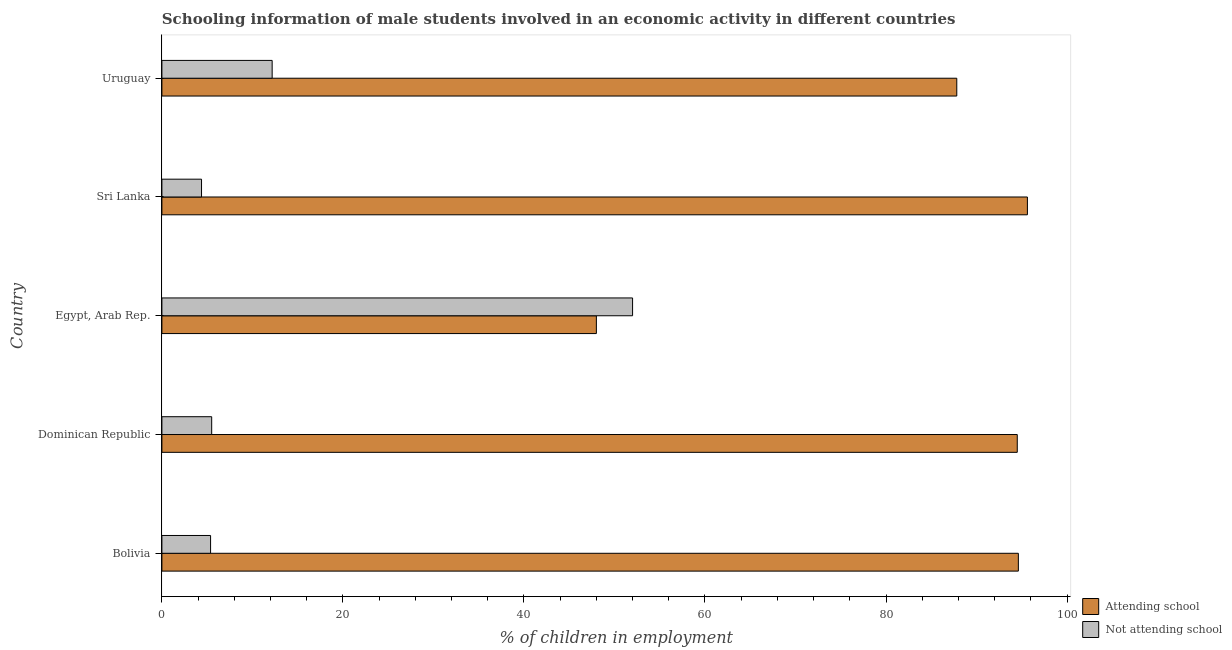How many groups of bars are there?
Your response must be concise. 5. How many bars are there on the 1st tick from the top?
Provide a succinct answer. 2. How many bars are there on the 5th tick from the bottom?
Make the answer very short. 2. What is the label of the 1st group of bars from the top?
Offer a very short reply. Uruguay. In how many cases, is the number of bars for a given country not equal to the number of legend labels?
Your answer should be very brief. 0. What is the percentage of employed males who are attending school in Sri Lanka?
Keep it short and to the point. 95.62. Across all countries, what is the minimum percentage of employed males who are not attending school?
Your response must be concise. 4.38. In which country was the percentage of employed males who are not attending school maximum?
Offer a very short reply. Egypt, Arab Rep. In which country was the percentage of employed males who are attending school minimum?
Give a very brief answer. Egypt, Arab Rep. What is the total percentage of employed males who are attending school in the graph?
Offer a terse response. 420.56. What is the difference between the percentage of employed males who are attending school in Egypt, Arab Rep. and that in Uruguay?
Make the answer very short. -39.82. What is the difference between the percentage of employed males who are not attending school in Bolivia and the percentage of employed males who are attending school in Uruguay?
Make the answer very short. -82.44. What is the average percentage of employed males who are not attending school per country?
Keep it short and to the point. 15.89. What is the difference between the percentage of employed males who are attending school and percentage of employed males who are not attending school in Bolivia?
Provide a short and direct response. 89.24. In how many countries, is the percentage of employed males who are attending school greater than 28 %?
Ensure brevity in your answer.  5. What is the ratio of the percentage of employed males who are not attending school in Egypt, Arab Rep. to that in Uruguay?
Your response must be concise. 4.27. Is the percentage of employed males who are not attending school in Bolivia less than that in Uruguay?
Your response must be concise. Yes. What is the difference between the highest and the second highest percentage of employed males who are attending school?
Provide a succinct answer. 1. What is the difference between the highest and the lowest percentage of employed males who are attending school?
Offer a terse response. 47.62. What does the 2nd bar from the top in Bolivia represents?
Offer a very short reply. Attending school. What does the 1st bar from the bottom in Egypt, Arab Rep. represents?
Provide a short and direct response. Attending school. How many bars are there?
Offer a very short reply. 10. Are all the bars in the graph horizontal?
Provide a succinct answer. Yes. What is the difference between two consecutive major ticks on the X-axis?
Give a very brief answer. 20. Are the values on the major ticks of X-axis written in scientific E-notation?
Provide a short and direct response. No. Does the graph contain any zero values?
Offer a very short reply. No. Where does the legend appear in the graph?
Keep it short and to the point. Bottom right. How many legend labels are there?
Offer a terse response. 2. What is the title of the graph?
Offer a very short reply. Schooling information of male students involved in an economic activity in different countries. What is the label or title of the X-axis?
Your response must be concise. % of children in employment. What is the % of children in employment of Attending school in Bolivia?
Make the answer very short. 94.62. What is the % of children in employment of Not attending school in Bolivia?
Make the answer very short. 5.38. What is the % of children in employment of Attending school in Dominican Republic?
Provide a succinct answer. 94.5. What is the % of children in employment in Not attending school in Egypt, Arab Rep.?
Keep it short and to the point. 52. What is the % of children in employment of Attending school in Sri Lanka?
Offer a very short reply. 95.62. What is the % of children in employment of Not attending school in Sri Lanka?
Offer a very short reply. 4.38. What is the % of children in employment of Attending school in Uruguay?
Keep it short and to the point. 87.82. What is the % of children in employment of Not attending school in Uruguay?
Offer a terse response. 12.18. Across all countries, what is the maximum % of children in employment in Attending school?
Provide a short and direct response. 95.62. Across all countries, what is the minimum % of children in employment in Not attending school?
Your answer should be compact. 4.38. What is the total % of children in employment in Attending school in the graph?
Your answer should be very brief. 420.56. What is the total % of children in employment in Not attending school in the graph?
Provide a succinct answer. 79.44. What is the difference between the % of children in employment of Attending school in Bolivia and that in Dominican Republic?
Provide a short and direct response. 0.12. What is the difference between the % of children in employment in Not attending school in Bolivia and that in Dominican Republic?
Make the answer very short. -0.12. What is the difference between the % of children in employment of Attending school in Bolivia and that in Egypt, Arab Rep.?
Provide a succinct answer. 46.62. What is the difference between the % of children in employment in Not attending school in Bolivia and that in Egypt, Arab Rep.?
Offer a very short reply. -46.62. What is the difference between the % of children in employment in Attending school in Bolivia and that in Sri Lanka?
Your answer should be compact. -1. What is the difference between the % of children in employment in Attending school in Bolivia and that in Uruguay?
Provide a succinct answer. 6.8. What is the difference between the % of children in employment in Not attending school in Bolivia and that in Uruguay?
Provide a succinct answer. -6.8. What is the difference between the % of children in employment in Attending school in Dominican Republic and that in Egypt, Arab Rep.?
Your answer should be very brief. 46.5. What is the difference between the % of children in employment in Not attending school in Dominican Republic and that in Egypt, Arab Rep.?
Ensure brevity in your answer.  -46.5. What is the difference between the % of children in employment of Attending school in Dominican Republic and that in Sri Lanka?
Give a very brief answer. -1.12. What is the difference between the % of children in employment of Not attending school in Dominican Republic and that in Sri Lanka?
Offer a terse response. 1.12. What is the difference between the % of children in employment in Attending school in Dominican Republic and that in Uruguay?
Provide a short and direct response. 6.68. What is the difference between the % of children in employment in Not attending school in Dominican Republic and that in Uruguay?
Keep it short and to the point. -6.68. What is the difference between the % of children in employment of Attending school in Egypt, Arab Rep. and that in Sri Lanka?
Give a very brief answer. -47.62. What is the difference between the % of children in employment of Not attending school in Egypt, Arab Rep. and that in Sri Lanka?
Offer a terse response. 47.62. What is the difference between the % of children in employment of Attending school in Egypt, Arab Rep. and that in Uruguay?
Give a very brief answer. -39.82. What is the difference between the % of children in employment of Not attending school in Egypt, Arab Rep. and that in Uruguay?
Make the answer very short. 39.82. What is the difference between the % of children in employment of Attending school in Sri Lanka and that in Uruguay?
Offer a terse response. 7.8. What is the difference between the % of children in employment of Not attending school in Sri Lanka and that in Uruguay?
Give a very brief answer. -7.8. What is the difference between the % of children in employment of Attending school in Bolivia and the % of children in employment of Not attending school in Dominican Republic?
Give a very brief answer. 89.12. What is the difference between the % of children in employment of Attending school in Bolivia and the % of children in employment of Not attending school in Egypt, Arab Rep.?
Your answer should be very brief. 42.62. What is the difference between the % of children in employment of Attending school in Bolivia and the % of children in employment of Not attending school in Sri Lanka?
Give a very brief answer. 90.24. What is the difference between the % of children in employment in Attending school in Bolivia and the % of children in employment in Not attending school in Uruguay?
Give a very brief answer. 82.44. What is the difference between the % of children in employment in Attending school in Dominican Republic and the % of children in employment in Not attending school in Egypt, Arab Rep.?
Offer a very short reply. 42.5. What is the difference between the % of children in employment in Attending school in Dominican Republic and the % of children in employment in Not attending school in Sri Lanka?
Your response must be concise. 90.12. What is the difference between the % of children in employment in Attending school in Dominican Republic and the % of children in employment in Not attending school in Uruguay?
Your answer should be compact. 82.32. What is the difference between the % of children in employment of Attending school in Egypt, Arab Rep. and the % of children in employment of Not attending school in Sri Lanka?
Keep it short and to the point. 43.62. What is the difference between the % of children in employment of Attending school in Egypt, Arab Rep. and the % of children in employment of Not attending school in Uruguay?
Keep it short and to the point. 35.82. What is the difference between the % of children in employment in Attending school in Sri Lanka and the % of children in employment in Not attending school in Uruguay?
Your answer should be compact. 83.44. What is the average % of children in employment in Attending school per country?
Offer a very short reply. 84.11. What is the average % of children in employment in Not attending school per country?
Provide a succinct answer. 15.89. What is the difference between the % of children in employment in Attending school and % of children in employment in Not attending school in Bolivia?
Provide a succinct answer. 89.24. What is the difference between the % of children in employment in Attending school and % of children in employment in Not attending school in Dominican Republic?
Your answer should be compact. 89. What is the difference between the % of children in employment in Attending school and % of children in employment in Not attending school in Egypt, Arab Rep.?
Make the answer very short. -4. What is the difference between the % of children in employment of Attending school and % of children in employment of Not attending school in Sri Lanka?
Your answer should be compact. 91.24. What is the difference between the % of children in employment in Attending school and % of children in employment in Not attending school in Uruguay?
Provide a short and direct response. 75.64. What is the ratio of the % of children in employment in Not attending school in Bolivia to that in Dominican Republic?
Offer a very short reply. 0.98. What is the ratio of the % of children in employment in Attending school in Bolivia to that in Egypt, Arab Rep.?
Ensure brevity in your answer.  1.97. What is the ratio of the % of children in employment of Not attending school in Bolivia to that in Egypt, Arab Rep.?
Provide a short and direct response. 0.1. What is the ratio of the % of children in employment in Attending school in Bolivia to that in Sri Lanka?
Your answer should be very brief. 0.99. What is the ratio of the % of children in employment of Not attending school in Bolivia to that in Sri Lanka?
Give a very brief answer. 1.23. What is the ratio of the % of children in employment of Attending school in Bolivia to that in Uruguay?
Make the answer very short. 1.08. What is the ratio of the % of children in employment in Not attending school in Bolivia to that in Uruguay?
Offer a very short reply. 0.44. What is the ratio of the % of children in employment of Attending school in Dominican Republic to that in Egypt, Arab Rep.?
Offer a terse response. 1.97. What is the ratio of the % of children in employment in Not attending school in Dominican Republic to that in Egypt, Arab Rep.?
Provide a succinct answer. 0.11. What is the ratio of the % of children in employment in Attending school in Dominican Republic to that in Sri Lanka?
Provide a short and direct response. 0.99. What is the ratio of the % of children in employment of Not attending school in Dominican Republic to that in Sri Lanka?
Provide a short and direct response. 1.26. What is the ratio of the % of children in employment of Attending school in Dominican Republic to that in Uruguay?
Make the answer very short. 1.08. What is the ratio of the % of children in employment of Not attending school in Dominican Republic to that in Uruguay?
Offer a very short reply. 0.45. What is the ratio of the % of children in employment in Attending school in Egypt, Arab Rep. to that in Sri Lanka?
Offer a terse response. 0.5. What is the ratio of the % of children in employment of Not attending school in Egypt, Arab Rep. to that in Sri Lanka?
Give a very brief answer. 11.87. What is the ratio of the % of children in employment in Attending school in Egypt, Arab Rep. to that in Uruguay?
Your response must be concise. 0.55. What is the ratio of the % of children in employment of Not attending school in Egypt, Arab Rep. to that in Uruguay?
Ensure brevity in your answer.  4.27. What is the ratio of the % of children in employment of Attending school in Sri Lanka to that in Uruguay?
Provide a succinct answer. 1.09. What is the ratio of the % of children in employment in Not attending school in Sri Lanka to that in Uruguay?
Your answer should be very brief. 0.36. What is the difference between the highest and the second highest % of children in employment of Attending school?
Your response must be concise. 1. What is the difference between the highest and the second highest % of children in employment of Not attending school?
Make the answer very short. 39.82. What is the difference between the highest and the lowest % of children in employment of Attending school?
Offer a terse response. 47.62. What is the difference between the highest and the lowest % of children in employment in Not attending school?
Offer a terse response. 47.62. 